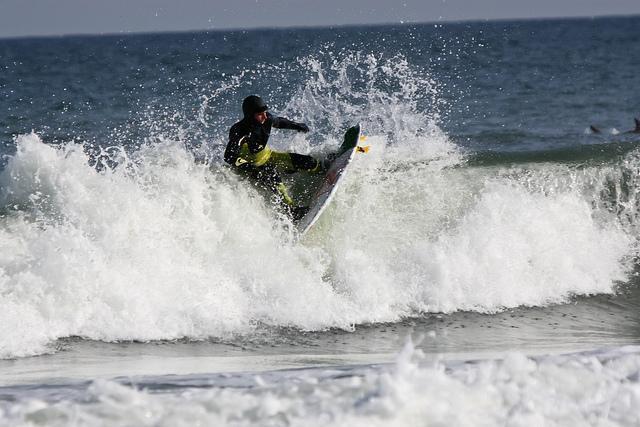How many people are surfing?
Give a very brief answer. 1. How many microwaves are there?
Give a very brief answer. 0. 